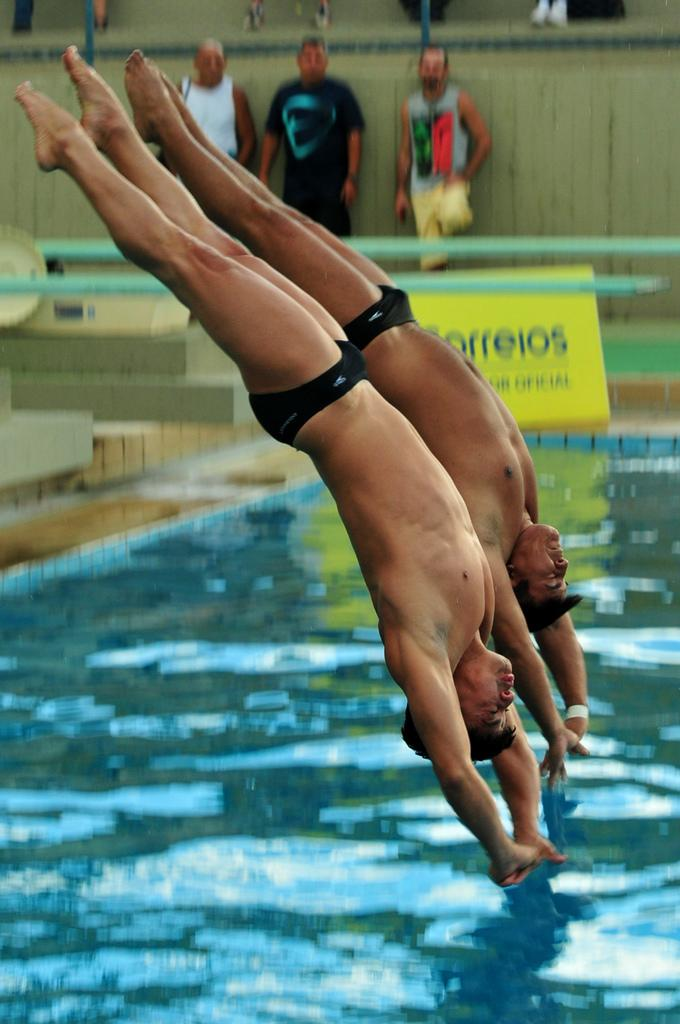What are the two men in the image doing? The two men are jumping into a pool. What are the three men in the image doing? The three men are standing in front of a wall. What can be seen beside the pool in the image? There is a yellow banner beside the pool. What scent can be detected from the quince tree in the image? There is no quince tree present in the image, so it is not possible to determine the scent. 